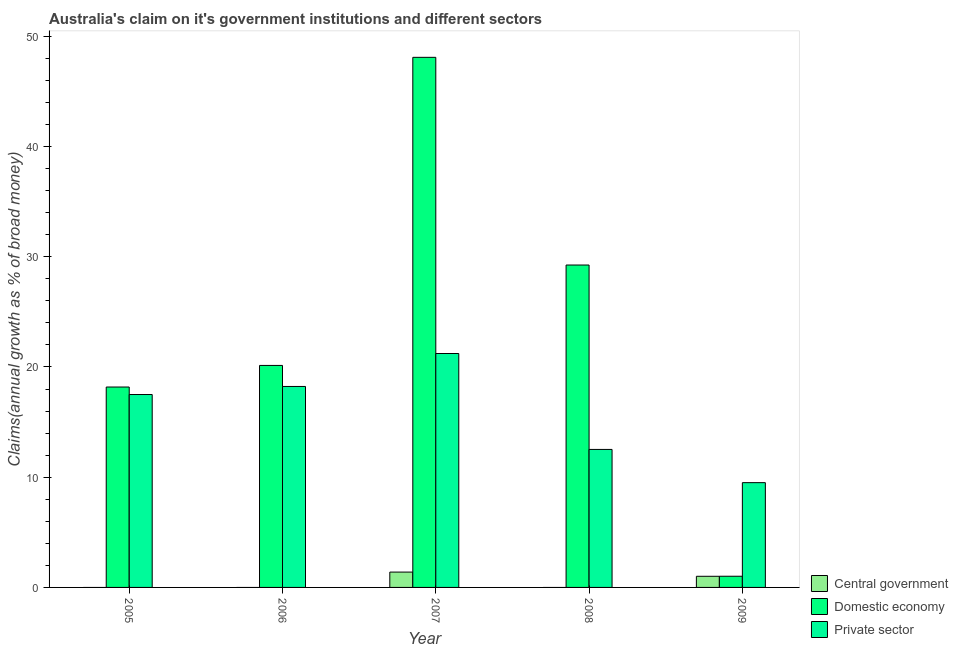How many different coloured bars are there?
Ensure brevity in your answer.  3. Are the number of bars on each tick of the X-axis equal?
Your response must be concise. No. How many bars are there on the 1st tick from the right?
Offer a terse response. 3. In how many cases, is the number of bars for a given year not equal to the number of legend labels?
Give a very brief answer. 3. What is the percentage of claim on the domestic economy in 2006?
Your answer should be very brief. 20.14. Across all years, what is the maximum percentage of claim on the private sector?
Your answer should be compact. 21.22. In which year was the percentage of claim on the central government maximum?
Provide a succinct answer. 2007. What is the total percentage of claim on the domestic economy in the graph?
Provide a short and direct response. 116.69. What is the difference between the percentage of claim on the domestic economy in 2005 and that in 2008?
Your answer should be very brief. -11.07. What is the difference between the percentage of claim on the domestic economy in 2007 and the percentage of claim on the central government in 2008?
Your answer should be compact. 18.84. What is the average percentage of claim on the domestic economy per year?
Provide a succinct answer. 23.34. In the year 2009, what is the difference between the percentage of claim on the private sector and percentage of claim on the domestic economy?
Provide a short and direct response. 0. What is the ratio of the percentage of claim on the domestic economy in 2006 to that in 2008?
Keep it short and to the point. 0.69. Is the difference between the percentage of claim on the domestic economy in 2006 and 2007 greater than the difference between the percentage of claim on the private sector in 2006 and 2007?
Give a very brief answer. No. What is the difference between the highest and the second highest percentage of claim on the private sector?
Your answer should be very brief. 2.99. What is the difference between the highest and the lowest percentage of claim on the domestic economy?
Provide a succinct answer. 47.08. Is the sum of the percentage of claim on the private sector in 2005 and 2006 greater than the maximum percentage of claim on the domestic economy across all years?
Provide a short and direct response. Yes. Is it the case that in every year, the sum of the percentage of claim on the central government and percentage of claim on the domestic economy is greater than the percentage of claim on the private sector?
Offer a terse response. No. Does the graph contain grids?
Make the answer very short. No. Where does the legend appear in the graph?
Give a very brief answer. Bottom right. How many legend labels are there?
Your answer should be compact. 3. How are the legend labels stacked?
Your answer should be very brief. Vertical. What is the title of the graph?
Ensure brevity in your answer.  Australia's claim on it's government institutions and different sectors. What is the label or title of the Y-axis?
Ensure brevity in your answer.  Claims(annual growth as % of broad money). What is the Claims(annual growth as % of broad money) in Central government in 2005?
Provide a succinct answer. 0. What is the Claims(annual growth as % of broad money) of Domestic economy in 2005?
Ensure brevity in your answer.  18.18. What is the Claims(annual growth as % of broad money) of Private sector in 2005?
Keep it short and to the point. 17.5. What is the Claims(annual growth as % of broad money) of Domestic economy in 2006?
Offer a very short reply. 20.14. What is the Claims(annual growth as % of broad money) of Private sector in 2006?
Keep it short and to the point. 18.23. What is the Claims(annual growth as % of broad money) in Central government in 2007?
Your answer should be compact. 1.39. What is the Claims(annual growth as % of broad money) in Domestic economy in 2007?
Your response must be concise. 48.1. What is the Claims(annual growth as % of broad money) in Private sector in 2007?
Your answer should be very brief. 21.22. What is the Claims(annual growth as % of broad money) of Domestic economy in 2008?
Your answer should be compact. 29.25. What is the Claims(annual growth as % of broad money) of Private sector in 2008?
Your answer should be compact. 12.52. What is the Claims(annual growth as % of broad money) of Central government in 2009?
Offer a very short reply. 1.01. What is the Claims(annual growth as % of broad money) in Domestic economy in 2009?
Your answer should be very brief. 1.01. What is the Claims(annual growth as % of broad money) in Private sector in 2009?
Keep it short and to the point. 9.51. Across all years, what is the maximum Claims(annual growth as % of broad money) of Central government?
Your answer should be compact. 1.39. Across all years, what is the maximum Claims(annual growth as % of broad money) in Domestic economy?
Provide a short and direct response. 48.1. Across all years, what is the maximum Claims(annual growth as % of broad money) of Private sector?
Your response must be concise. 21.22. Across all years, what is the minimum Claims(annual growth as % of broad money) in Domestic economy?
Keep it short and to the point. 1.01. Across all years, what is the minimum Claims(annual growth as % of broad money) of Private sector?
Offer a very short reply. 9.51. What is the total Claims(annual growth as % of broad money) of Central government in the graph?
Your response must be concise. 2.4. What is the total Claims(annual growth as % of broad money) in Domestic economy in the graph?
Your response must be concise. 116.69. What is the total Claims(annual growth as % of broad money) of Private sector in the graph?
Provide a short and direct response. 78.99. What is the difference between the Claims(annual growth as % of broad money) in Domestic economy in 2005 and that in 2006?
Ensure brevity in your answer.  -1.96. What is the difference between the Claims(annual growth as % of broad money) in Private sector in 2005 and that in 2006?
Your response must be concise. -0.73. What is the difference between the Claims(annual growth as % of broad money) of Domestic economy in 2005 and that in 2007?
Your answer should be very brief. -29.91. What is the difference between the Claims(annual growth as % of broad money) in Private sector in 2005 and that in 2007?
Provide a short and direct response. -3.72. What is the difference between the Claims(annual growth as % of broad money) in Domestic economy in 2005 and that in 2008?
Provide a short and direct response. -11.07. What is the difference between the Claims(annual growth as % of broad money) in Private sector in 2005 and that in 2008?
Keep it short and to the point. 4.98. What is the difference between the Claims(annual growth as % of broad money) in Domestic economy in 2005 and that in 2009?
Give a very brief answer. 17.17. What is the difference between the Claims(annual growth as % of broad money) in Private sector in 2005 and that in 2009?
Offer a terse response. 8. What is the difference between the Claims(annual growth as % of broad money) of Domestic economy in 2006 and that in 2007?
Keep it short and to the point. -27.95. What is the difference between the Claims(annual growth as % of broad money) in Private sector in 2006 and that in 2007?
Provide a succinct answer. -2.99. What is the difference between the Claims(annual growth as % of broad money) in Domestic economy in 2006 and that in 2008?
Your answer should be compact. -9.11. What is the difference between the Claims(annual growth as % of broad money) of Private sector in 2006 and that in 2008?
Make the answer very short. 5.71. What is the difference between the Claims(annual growth as % of broad money) of Domestic economy in 2006 and that in 2009?
Make the answer very short. 19.13. What is the difference between the Claims(annual growth as % of broad money) of Private sector in 2006 and that in 2009?
Ensure brevity in your answer.  8.73. What is the difference between the Claims(annual growth as % of broad money) of Domestic economy in 2007 and that in 2008?
Provide a succinct answer. 18.84. What is the difference between the Claims(annual growth as % of broad money) of Private sector in 2007 and that in 2008?
Keep it short and to the point. 8.7. What is the difference between the Claims(annual growth as % of broad money) of Central government in 2007 and that in 2009?
Provide a succinct answer. 0.38. What is the difference between the Claims(annual growth as % of broad money) of Domestic economy in 2007 and that in 2009?
Keep it short and to the point. 47.08. What is the difference between the Claims(annual growth as % of broad money) of Private sector in 2007 and that in 2009?
Provide a succinct answer. 11.72. What is the difference between the Claims(annual growth as % of broad money) of Domestic economy in 2008 and that in 2009?
Your answer should be very brief. 28.24. What is the difference between the Claims(annual growth as % of broad money) in Private sector in 2008 and that in 2009?
Make the answer very short. 3.01. What is the difference between the Claims(annual growth as % of broad money) in Domestic economy in 2005 and the Claims(annual growth as % of broad money) in Private sector in 2006?
Keep it short and to the point. -0.05. What is the difference between the Claims(annual growth as % of broad money) in Domestic economy in 2005 and the Claims(annual growth as % of broad money) in Private sector in 2007?
Provide a succinct answer. -3.04. What is the difference between the Claims(annual growth as % of broad money) in Domestic economy in 2005 and the Claims(annual growth as % of broad money) in Private sector in 2008?
Provide a short and direct response. 5.66. What is the difference between the Claims(annual growth as % of broad money) of Domestic economy in 2005 and the Claims(annual growth as % of broad money) of Private sector in 2009?
Your answer should be compact. 8.68. What is the difference between the Claims(annual growth as % of broad money) in Domestic economy in 2006 and the Claims(annual growth as % of broad money) in Private sector in 2007?
Offer a very short reply. -1.08. What is the difference between the Claims(annual growth as % of broad money) of Domestic economy in 2006 and the Claims(annual growth as % of broad money) of Private sector in 2008?
Provide a short and direct response. 7.62. What is the difference between the Claims(annual growth as % of broad money) in Domestic economy in 2006 and the Claims(annual growth as % of broad money) in Private sector in 2009?
Make the answer very short. 10.63. What is the difference between the Claims(annual growth as % of broad money) of Central government in 2007 and the Claims(annual growth as % of broad money) of Domestic economy in 2008?
Provide a succinct answer. -27.86. What is the difference between the Claims(annual growth as % of broad money) in Central government in 2007 and the Claims(annual growth as % of broad money) in Private sector in 2008?
Your response must be concise. -11.13. What is the difference between the Claims(annual growth as % of broad money) of Domestic economy in 2007 and the Claims(annual growth as % of broad money) of Private sector in 2008?
Give a very brief answer. 35.58. What is the difference between the Claims(annual growth as % of broad money) of Central government in 2007 and the Claims(annual growth as % of broad money) of Domestic economy in 2009?
Provide a succinct answer. 0.38. What is the difference between the Claims(annual growth as % of broad money) of Central government in 2007 and the Claims(annual growth as % of broad money) of Private sector in 2009?
Offer a terse response. -8.12. What is the difference between the Claims(annual growth as % of broad money) of Domestic economy in 2007 and the Claims(annual growth as % of broad money) of Private sector in 2009?
Offer a terse response. 38.59. What is the difference between the Claims(annual growth as % of broad money) in Domestic economy in 2008 and the Claims(annual growth as % of broad money) in Private sector in 2009?
Offer a very short reply. 19.75. What is the average Claims(annual growth as % of broad money) in Central government per year?
Ensure brevity in your answer.  0.48. What is the average Claims(annual growth as % of broad money) in Domestic economy per year?
Give a very brief answer. 23.34. What is the average Claims(annual growth as % of broad money) of Private sector per year?
Your answer should be compact. 15.8. In the year 2005, what is the difference between the Claims(annual growth as % of broad money) of Domestic economy and Claims(annual growth as % of broad money) of Private sector?
Ensure brevity in your answer.  0.68. In the year 2006, what is the difference between the Claims(annual growth as % of broad money) of Domestic economy and Claims(annual growth as % of broad money) of Private sector?
Provide a succinct answer. 1.91. In the year 2007, what is the difference between the Claims(annual growth as % of broad money) in Central government and Claims(annual growth as % of broad money) in Domestic economy?
Make the answer very short. -46.7. In the year 2007, what is the difference between the Claims(annual growth as % of broad money) of Central government and Claims(annual growth as % of broad money) of Private sector?
Provide a succinct answer. -19.83. In the year 2007, what is the difference between the Claims(annual growth as % of broad money) in Domestic economy and Claims(annual growth as % of broad money) in Private sector?
Provide a short and direct response. 26.87. In the year 2008, what is the difference between the Claims(annual growth as % of broad money) in Domestic economy and Claims(annual growth as % of broad money) in Private sector?
Your response must be concise. 16.73. In the year 2009, what is the difference between the Claims(annual growth as % of broad money) of Central government and Claims(annual growth as % of broad money) of Domestic economy?
Keep it short and to the point. -0. In the year 2009, what is the difference between the Claims(annual growth as % of broad money) in Central government and Claims(annual growth as % of broad money) in Private sector?
Provide a succinct answer. -8.5. In the year 2009, what is the difference between the Claims(annual growth as % of broad money) of Domestic economy and Claims(annual growth as % of broad money) of Private sector?
Offer a terse response. -8.49. What is the ratio of the Claims(annual growth as % of broad money) in Domestic economy in 2005 to that in 2006?
Offer a terse response. 0.9. What is the ratio of the Claims(annual growth as % of broad money) in Private sector in 2005 to that in 2006?
Provide a short and direct response. 0.96. What is the ratio of the Claims(annual growth as % of broad money) in Domestic economy in 2005 to that in 2007?
Offer a very short reply. 0.38. What is the ratio of the Claims(annual growth as % of broad money) of Private sector in 2005 to that in 2007?
Make the answer very short. 0.82. What is the ratio of the Claims(annual growth as % of broad money) of Domestic economy in 2005 to that in 2008?
Give a very brief answer. 0.62. What is the ratio of the Claims(annual growth as % of broad money) in Private sector in 2005 to that in 2008?
Offer a terse response. 1.4. What is the ratio of the Claims(annual growth as % of broad money) in Domestic economy in 2005 to that in 2009?
Ensure brevity in your answer.  17.92. What is the ratio of the Claims(annual growth as % of broad money) in Private sector in 2005 to that in 2009?
Give a very brief answer. 1.84. What is the ratio of the Claims(annual growth as % of broad money) of Domestic economy in 2006 to that in 2007?
Your response must be concise. 0.42. What is the ratio of the Claims(annual growth as % of broad money) in Private sector in 2006 to that in 2007?
Offer a terse response. 0.86. What is the ratio of the Claims(annual growth as % of broad money) of Domestic economy in 2006 to that in 2008?
Your answer should be very brief. 0.69. What is the ratio of the Claims(annual growth as % of broad money) in Private sector in 2006 to that in 2008?
Your answer should be compact. 1.46. What is the ratio of the Claims(annual growth as % of broad money) in Domestic economy in 2006 to that in 2009?
Make the answer very short. 19.85. What is the ratio of the Claims(annual growth as % of broad money) of Private sector in 2006 to that in 2009?
Provide a succinct answer. 1.92. What is the ratio of the Claims(annual growth as % of broad money) in Domestic economy in 2007 to that in 2008?
Give a very brief answer. 1.64. What is the ratio of the Claims(annual growth as % of broad money) of Private sector in 2007 to that in 2008?
Give a very brief answer. 1.7. What is the ratio of the Claims(annual growth as % of broad money) in Central government in 2007 to that in 2009?
Give a very brief answer. 1.38. What is the ratio of the Claims(annual growth as % of broad money) of Domestic economy in 2007 to that in 2009?
Provide a short and direct response. 47.4. What is the ratio of the Claims(annual growth as % of broad money) of Private sector in 2007 to that in 2009?
Provide a succinct answer. 2.23. What is the ratio of the Claims(annual growth as % of broad money) of Domestic economy in 2008 to that in 2009?
Offer a terse response. 28.83. What is the ratio of the Claims(annual growth as % of broad money) of Private sector in 2008 to that in 2009?
Provide a short and direct response. 1.32. What is the difference between the highest and the second highest Claims(annual growth as % of broad money) in Domestic economy?
Offer a very short reply. 18.84. What is the difference between the highest and the second highest Claims(annual growth as % of broad money) in Private sector?
Make the answer very short. 2.99. What is the difference between the highest and the lowest Claims(annual growth as % of broad money) in Central government?
Ensure brevity in your answer.  1.39. What is the difference between the highest and the lowest Claims(annual growth as % of broad money) in Domestic economy?
Provide a short and direct response. 47.08. What is the difference between the highest and the lowest Claims(annual growth as % of broad money) in Private sector?
Offer a very short reply. 11.72. 